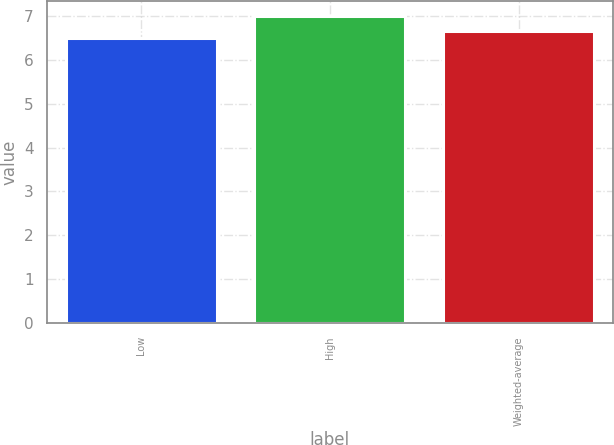<chart> <loc_0><loc_0><loc_500><loc_500><bar_chart><fcel>Low<fcel>High<fcel>Weighted-average<nl><fcel>6.5<fcel>7<fcel>6.66<nl></chart> 